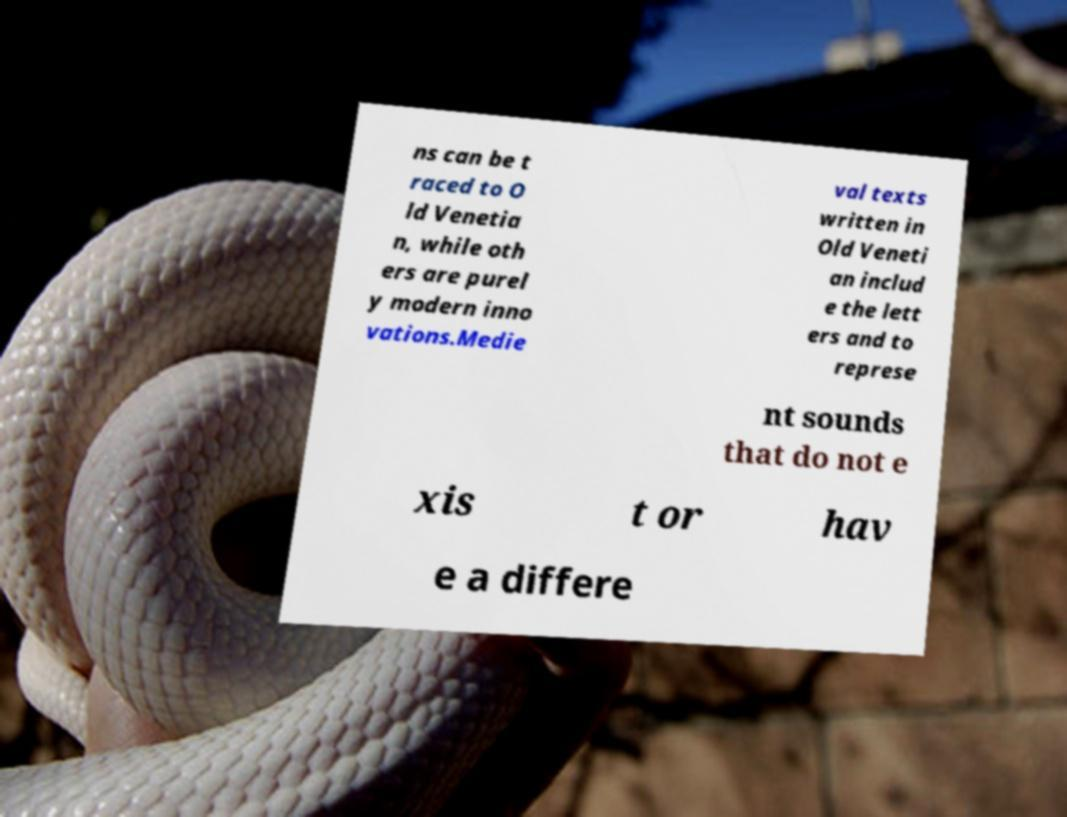What messages or text are displayed in this image? I need them in a readable, typed format. ns can be t raced to O ld Venetia n, while oth ers are purel y modern inno vations.Medie val texts written in Old Veneti an includ e the lett ers and to represe nt sounds that do not e xis t or hav e a differe 